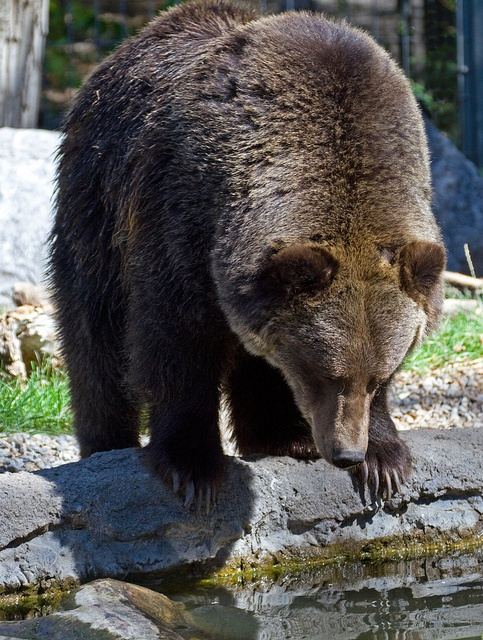Describe the objects in this image and their specific colors. I can see a bear in gray, black, and darkgray tones in this image. 